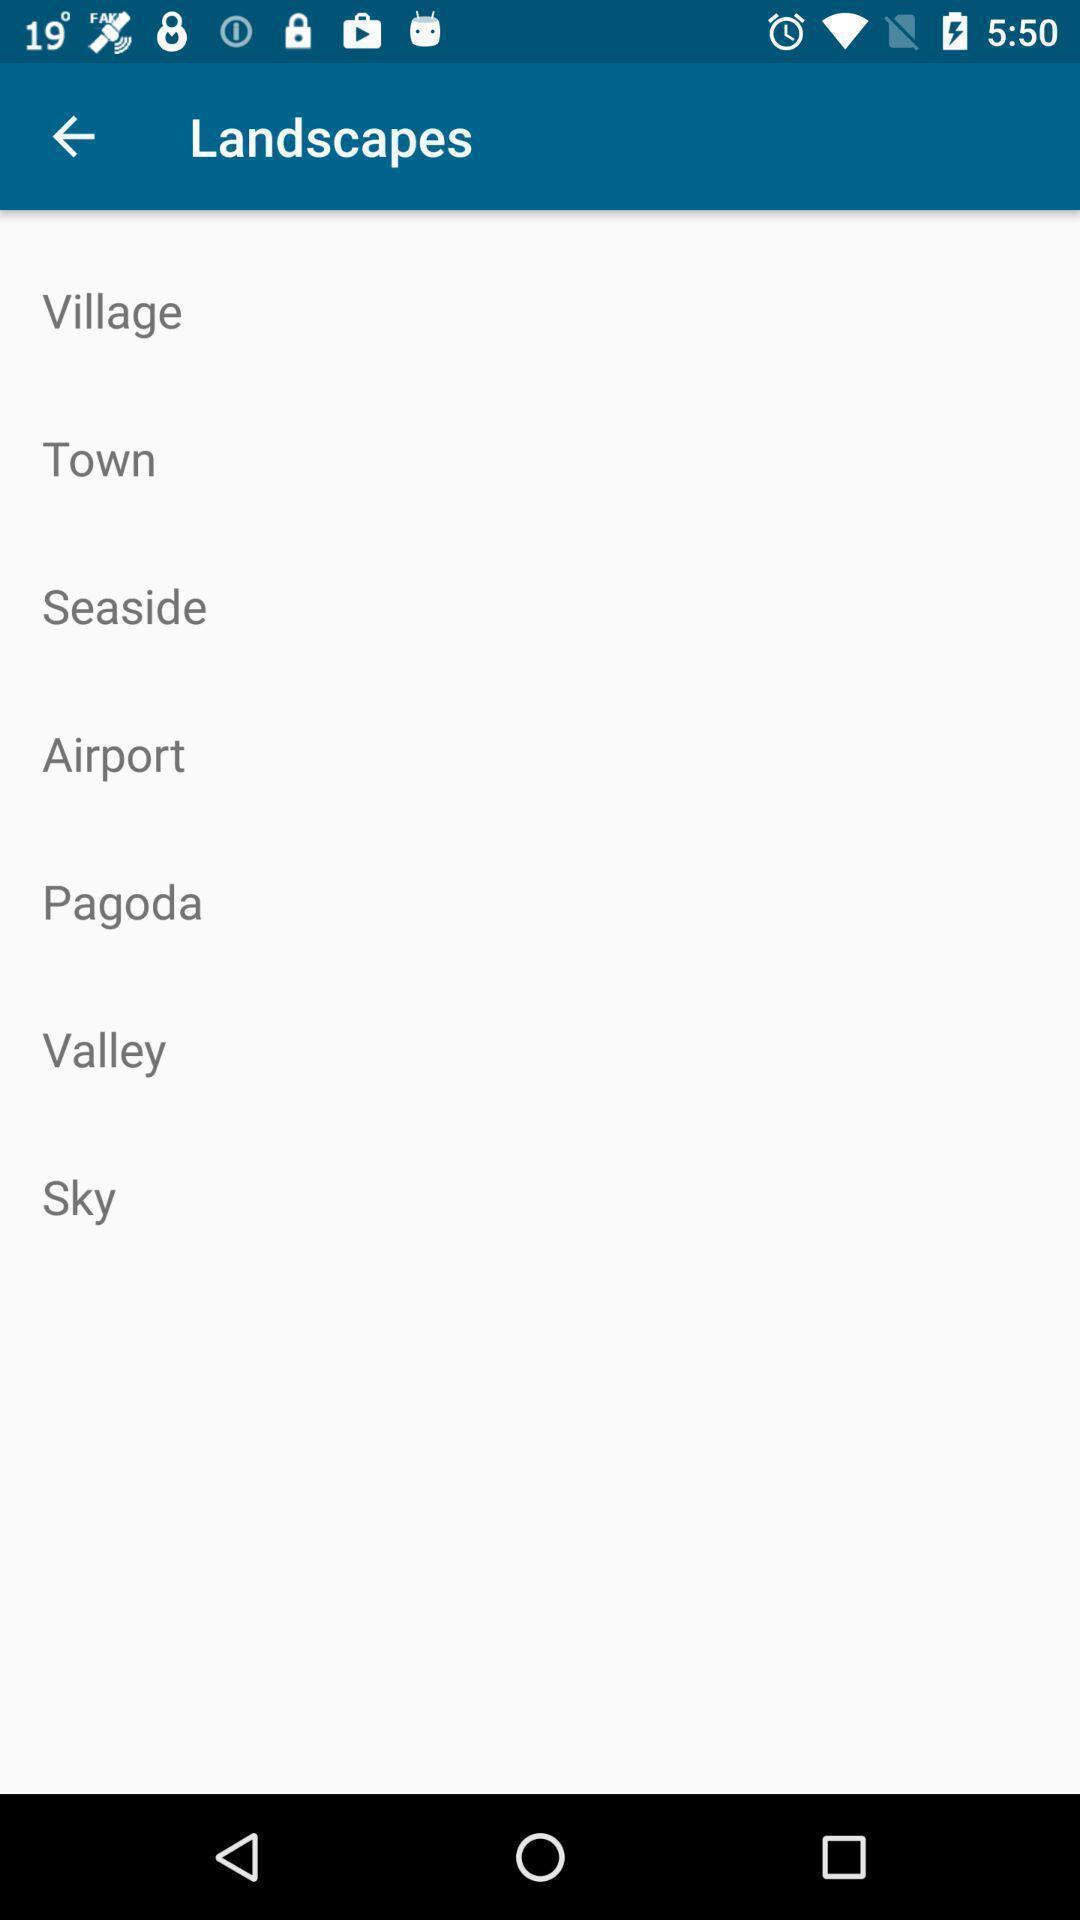Please provide a description for this image. Page for landscape with few options in a weather application. 